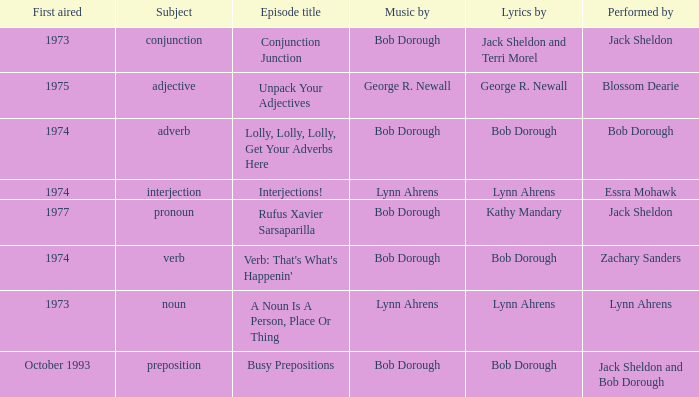When zachary sanders is the performer how many first aired are there? 1.0. 